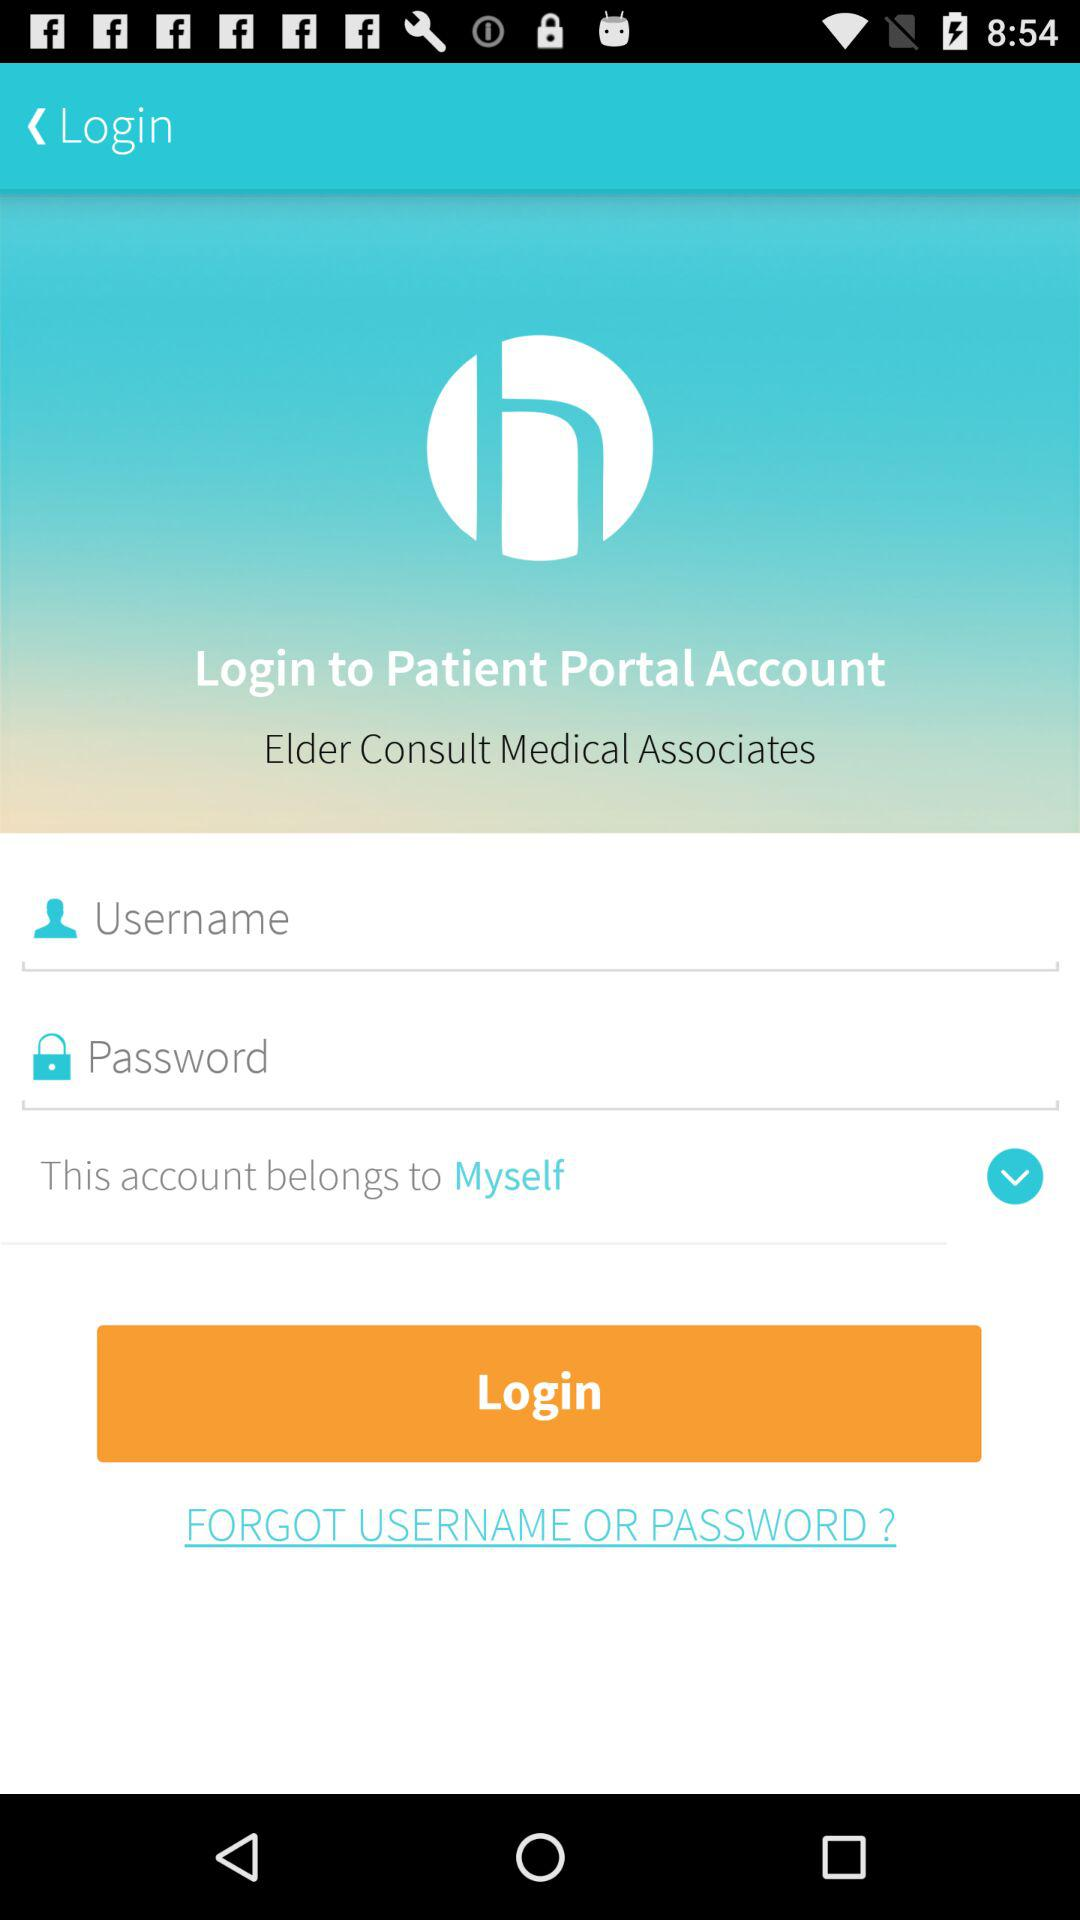How many textboxes are there in this login screen?
Answer the question using a single word or phrase. 2 